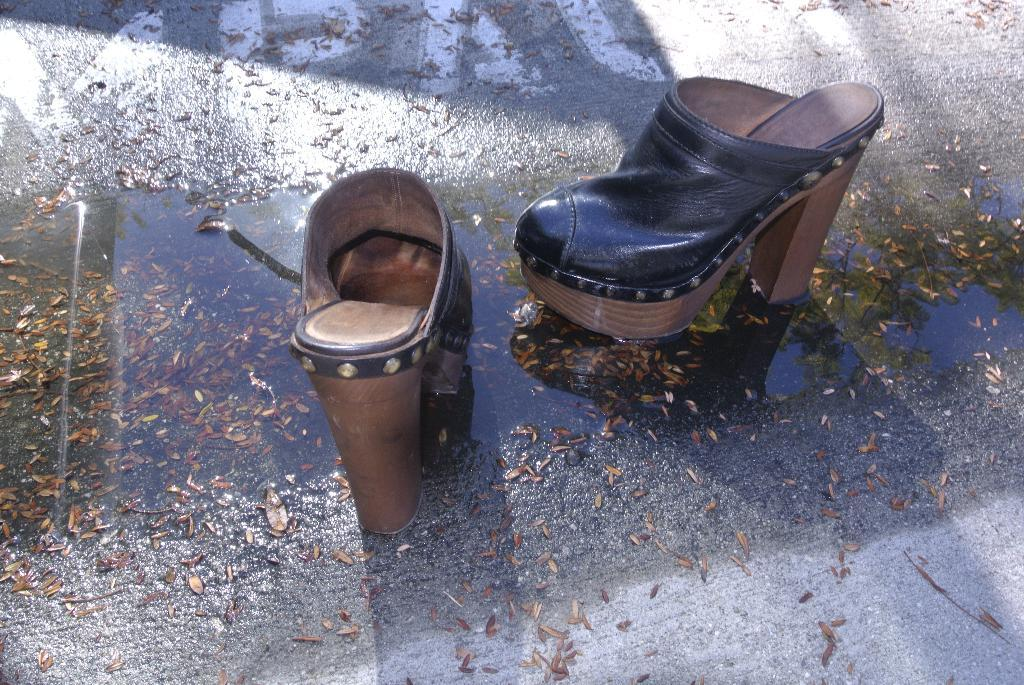What type of footwear is visible in the image? There are sandals in the image. What natural material can be seen in the image? Dry leaves are present in the image. What is the condition of the road in the image? There is water on the road in the image. What type of meal is being prepared in the image? There is no meal preparation visible in the image; it only features sandals, dry leaves, and water on the road. What type of pleasure can be seen in the image? There is no pleasure activity depicted in the image; it only features sandals, dry leaves, and water on the road. 